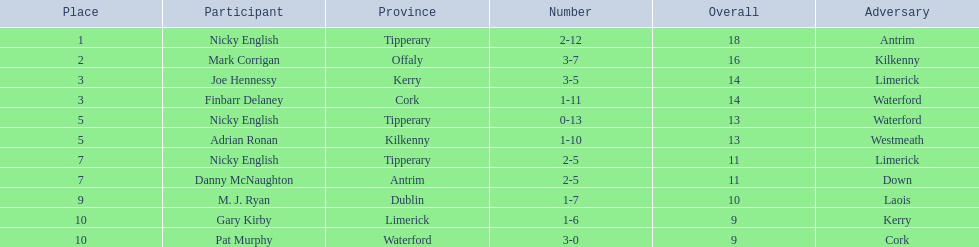What numbers are in the total column? 18, 16, 14, 14, 13, 13, 11, 11, 10, 9, 9. What row has the number 10 in the total column? 9, M. J. Ryan, Dublin, 1-7, 10, Laois. What name is in the player column for this row? M. J. Ryan. 